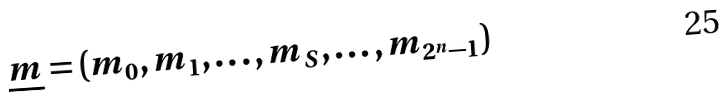Convert formula to latex. <formula><loc_0><loc_0><loc_500><loc_500>\underline { m } = \left ( m _ { 0 } , m _ { 1 } , \dots , m _ { S } , \dots , m _ { 2 ^ { n } - 1 } \right )</formula> 